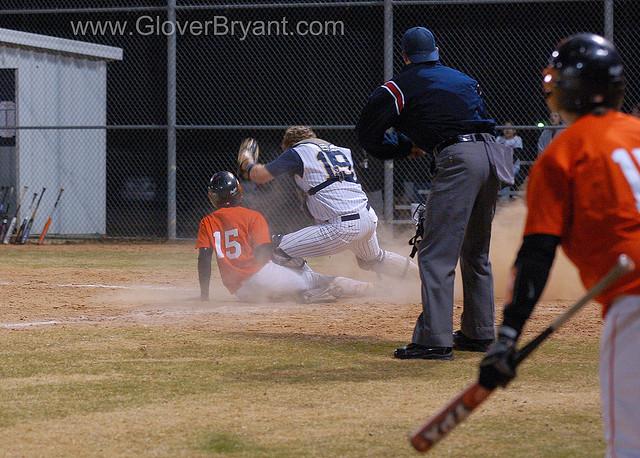How many people do you see on the field?
Answer briefly. 4. Is the player with number 15 hitting a ball?
Answer briefly. No. What number is the player on the left side?
Be succinct. 15. 